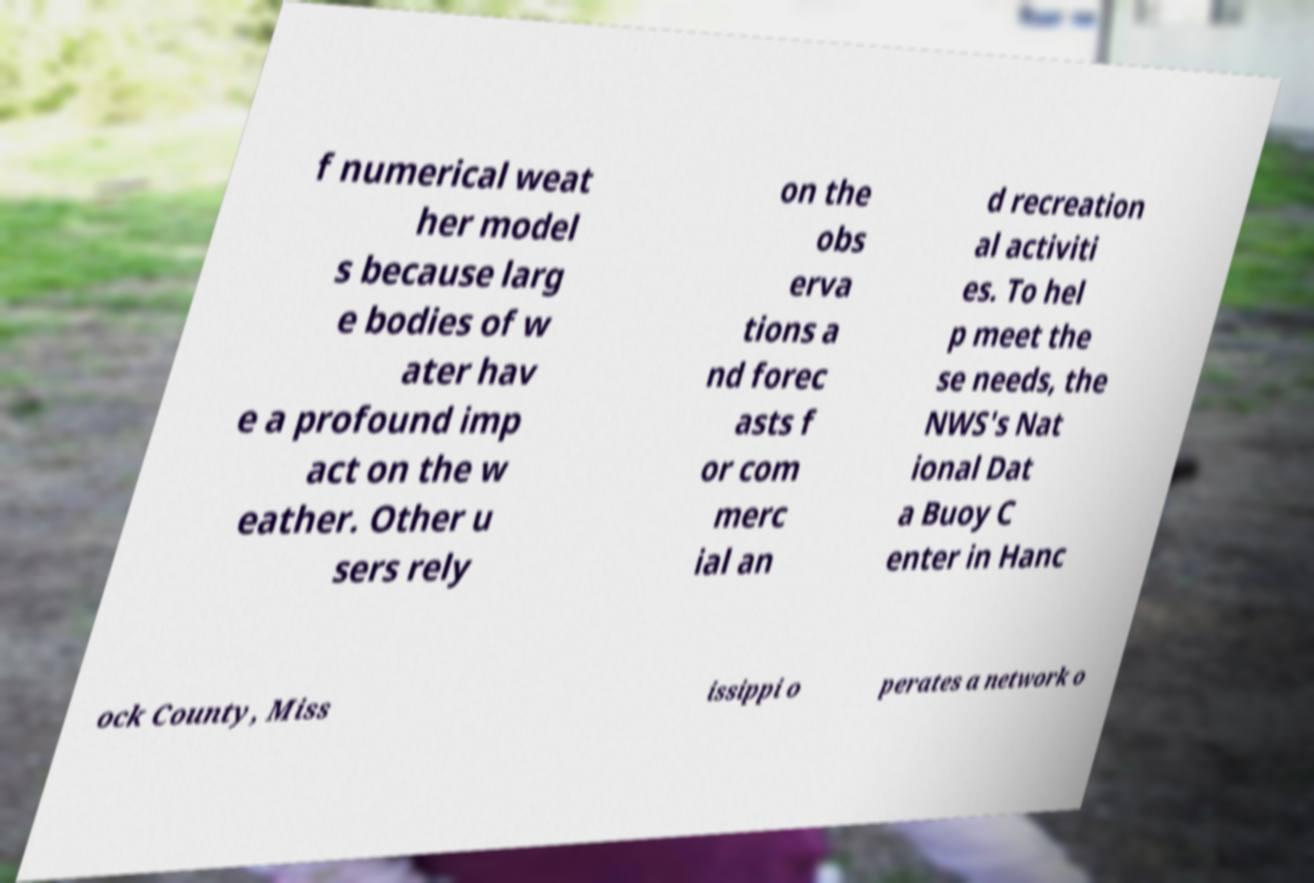Can you accurately transcribe the text from the provided image for me? f numerical weat her model s because larg e bodies of w ater hav e a profound imp act on the w eather. Other u sers rely on the obs erva tions a nd forec asts f or com merc ial an d recreation al activiti es. To hel p meet the se needs, the NWS's Nat ional Dat a Buoy C enter in Hanc ock County, Miss issippi o perates a network o 